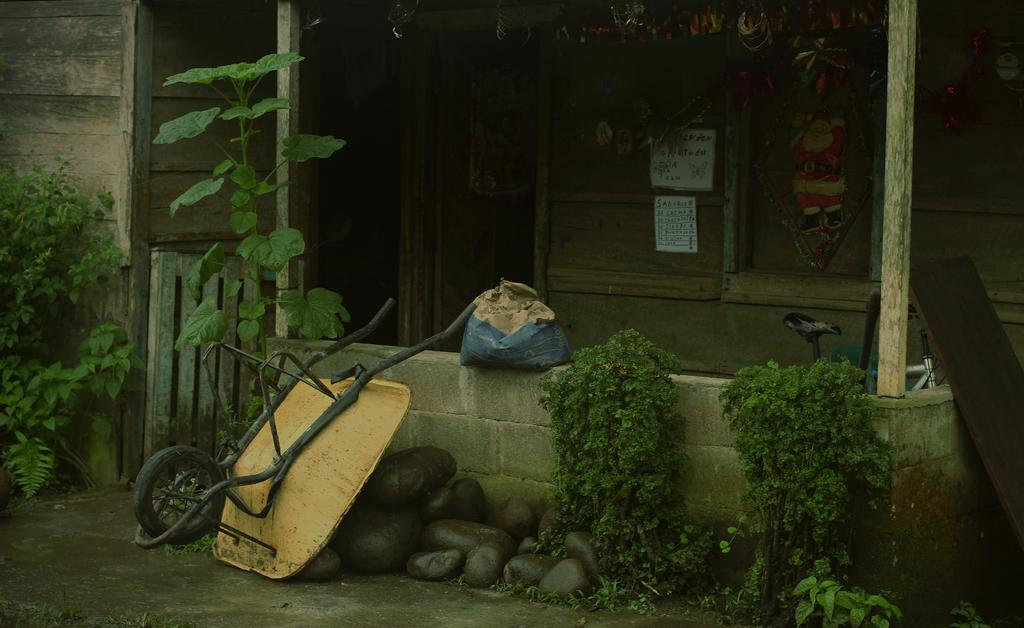What is the main object in the image? There is a trolley in the image. Can you describe anything hanging on the wall? There is a bag on the wall in the image. What type of plants are present in the image? There are plants in green color in the image. What kind of natural elements can be seen in the image? There are stones visible in the image. What is visible in the background of the image? There is a house and papers attached to a wooden surface in the background of the image. How many loaves of bread are on the trolley in the image? There is no loaf of bread present on the trolley in the image. How many girls are visible in the image? There are no girls visible in the image. 